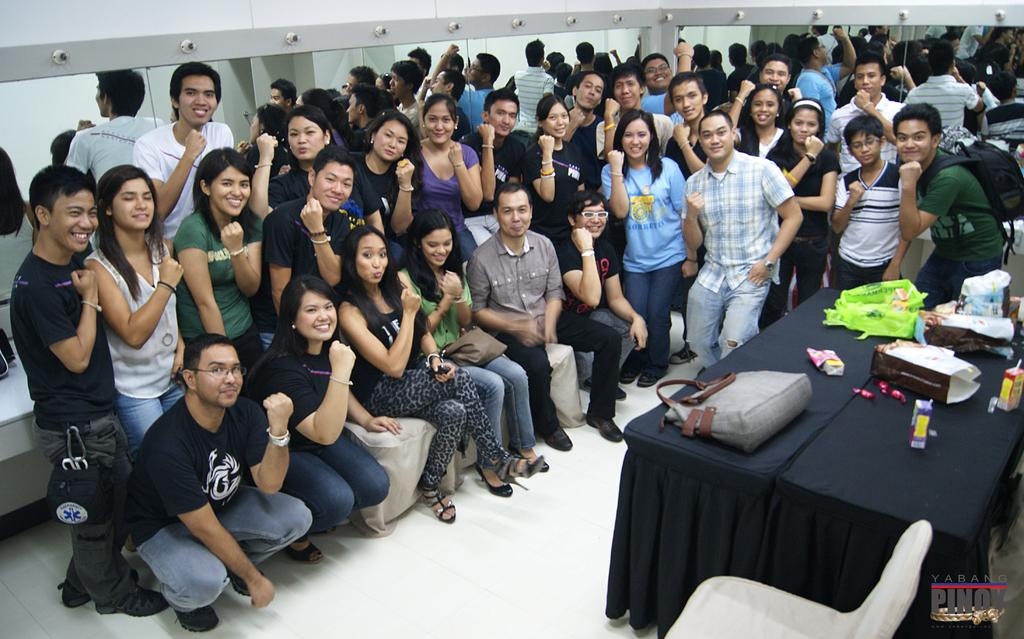How many people are in the image? There is a group of people in the image, but the exact number cannot be determined from the provided facts. What are the people in the image doing? Some people are sitting in the front, while others are standing behind, and they are posing for a camera. What are the people showing in the image? They are showing their wrists. What can be seen on the table in the image? There is a table with items on it in the image, but the specific items cannot be determined from the provided facts. What is the current state of the expansion of the universe in the image? The image does not depict the expansion of the universe or any related concepts; it features a group of people posing for a camera. 